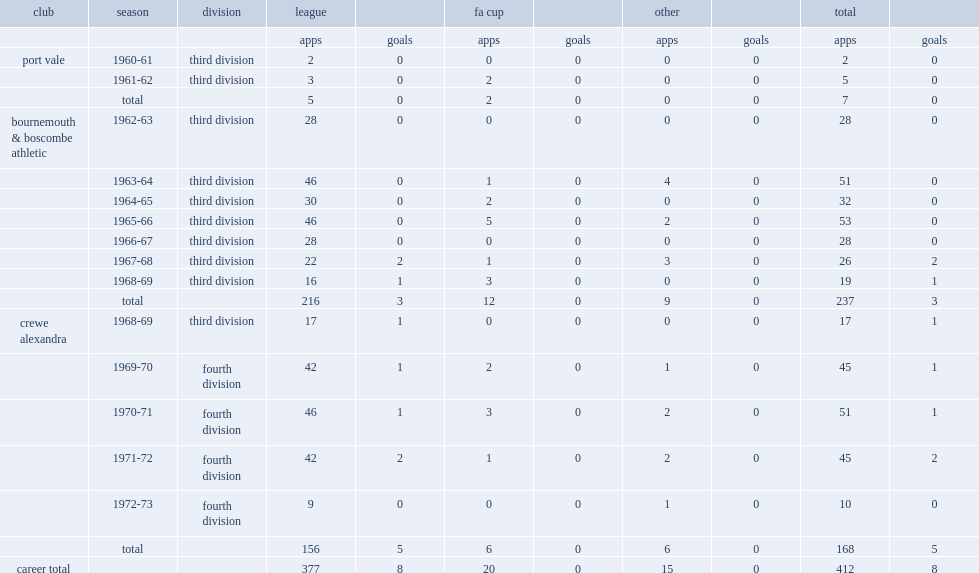What was the number of league and cup appearances made by roy gater totally? 412.0. 